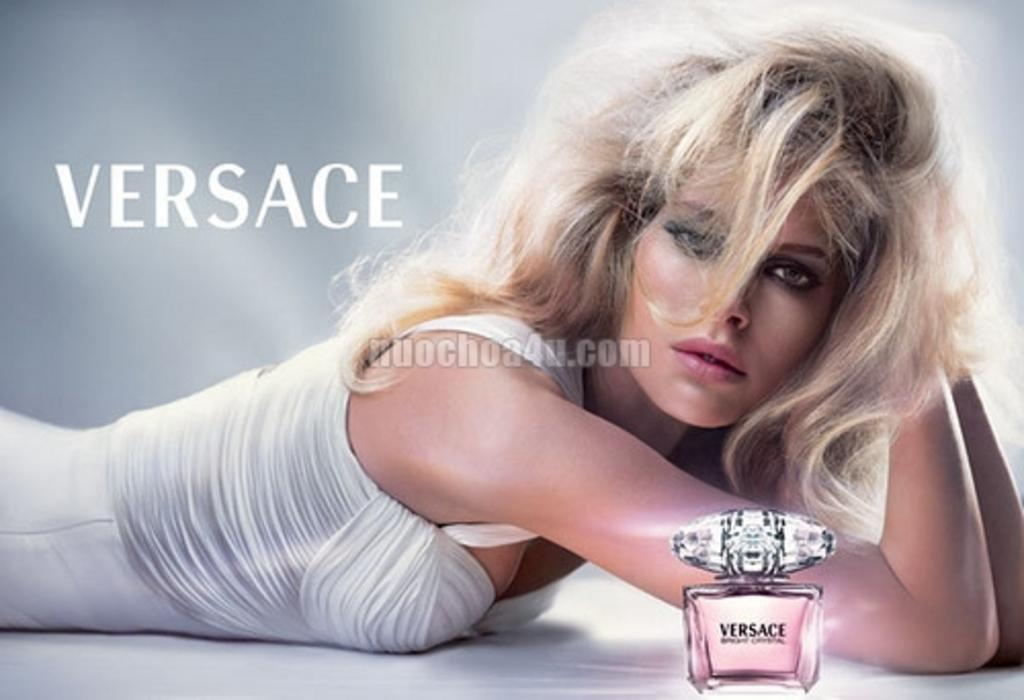<image>
Write a terse but informative summary of the picture. An advertisement for versace branded perfume with a model on the background. 